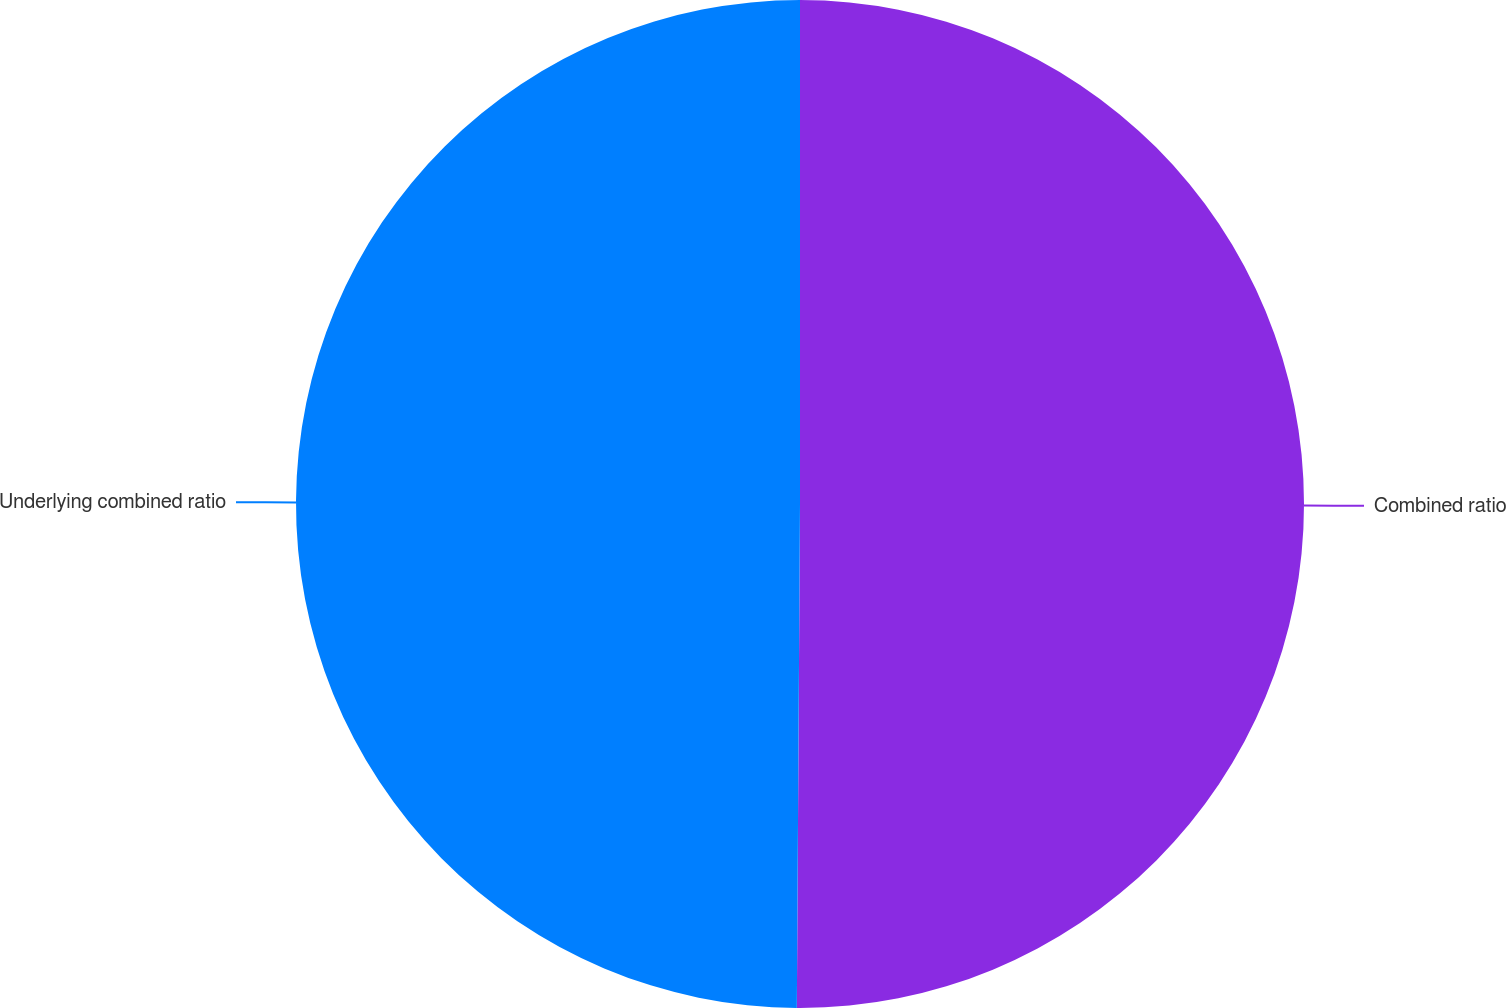<chart> <loc_0><loc_0><loc_500><loc_500><pie_chart><fcel>Combined ratio<fcel>Underlying combined ratio<nl><fcel>50.1%<fcel>49.9%<nl></chart> 